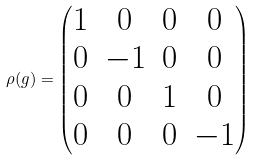Convert formula to latex. <formula><loc_0><loc_0><loc_500><loc_500>\rho ( g ) = \begin{pmatrix} 1 & 0 & 0 & 0 \\ 0 & - 1 & 0 & 0 \\ 0 & 0 & 1 & 0 \\ 0 & 0 & 0 & - 1 \end{pmatrix}</formula> 